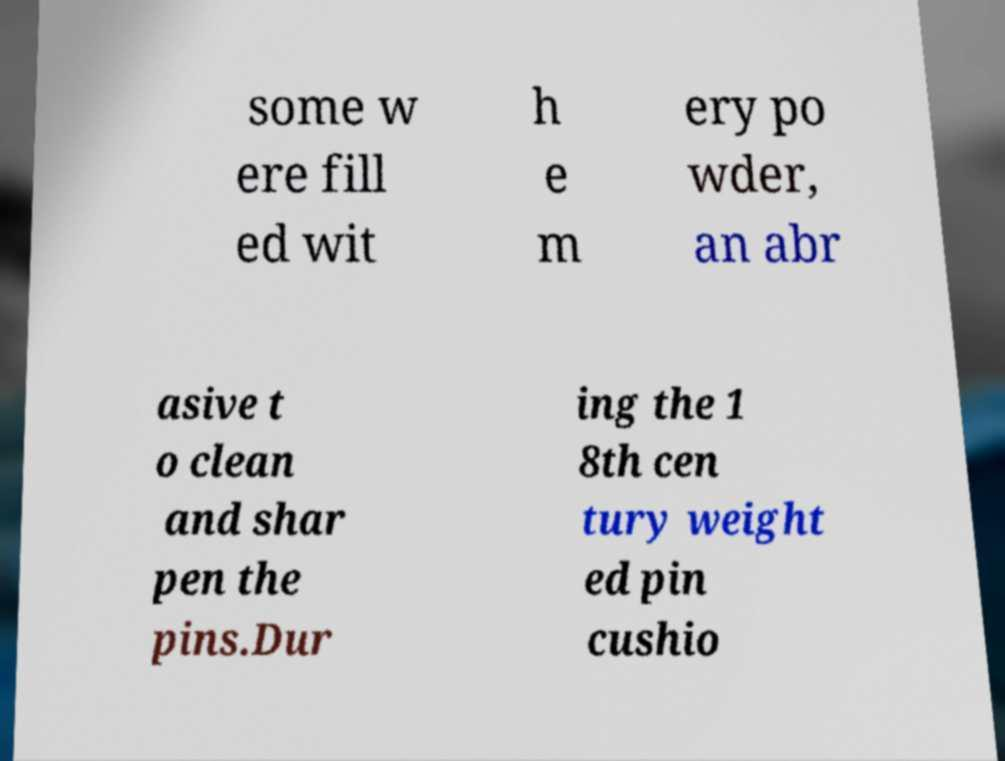Could you extract and type out the text from this image? some w ere fill ed wit h e m ery po wder, an abr asive t o clean and shar pen the pins.Dur ing the 1 8th cen tury weight ed pin cushio 